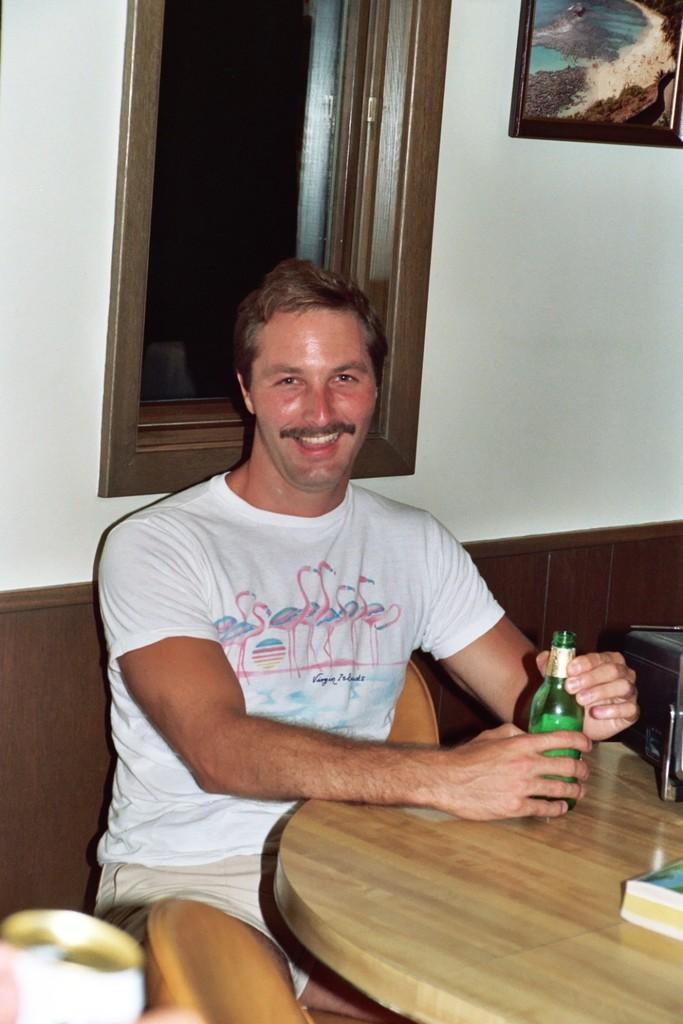What is the man in the image doing? The man is sitting on a bench in the image. What is the man holding in his hand? The man is holding a bottle in his hand. What is in front of the man? There is a table in front of the man. What is visible behind the man? There is a window behind the man. What can be seen on the wall in the image? A painting is present on the wall. What type of metal is the man using to control the bath in the image? There is no mention of a bath or metal in the image; the man is sitting on a bench and holding a bottle. 